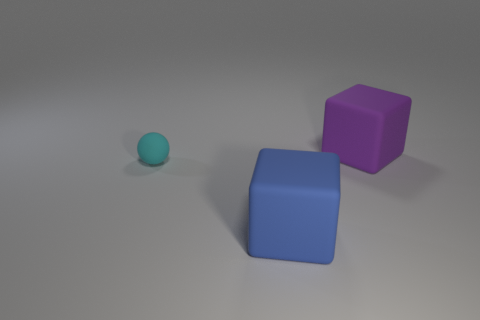What number of purple objects have the same size as the blue object?
Ensure brevity in your answer.  1. How many blue things are the same shape as the purple thing?
Offer a very short reply. 1. What shape is the tiny cyan object that is made of the same material as the blue object?
Provide a succinct answer. Sphere. There is a big matte object that is on the left side of the matte object to the right of the cube that is in front of the sphere; what shape is it?
Make the answer very short. Cube. Is the number of small spheres greater than the number of tiny metal objects?
Your response must be concise. Yes. There is a purple thing that is the same shape as the blue thing; what is its material?
Keep it short and to the point. Rubber. Is the small cyan object made of the same material as the big blue block?
Your answer should be very brief. Yes. Is the number of large blocks in front of the cyan thing greater than the number of yellow metallic things?
Provide a succinct answer. Yes. What is the material of the block behind the big matte block on the left side of the big thing behind the cyan rubber thing?
Your answer should be very brief. Rubber. What number of things are small cyan shiny blocks or matte objects that are on the left side of the large purple rubber thing?
Offer a very short reply. 2. 